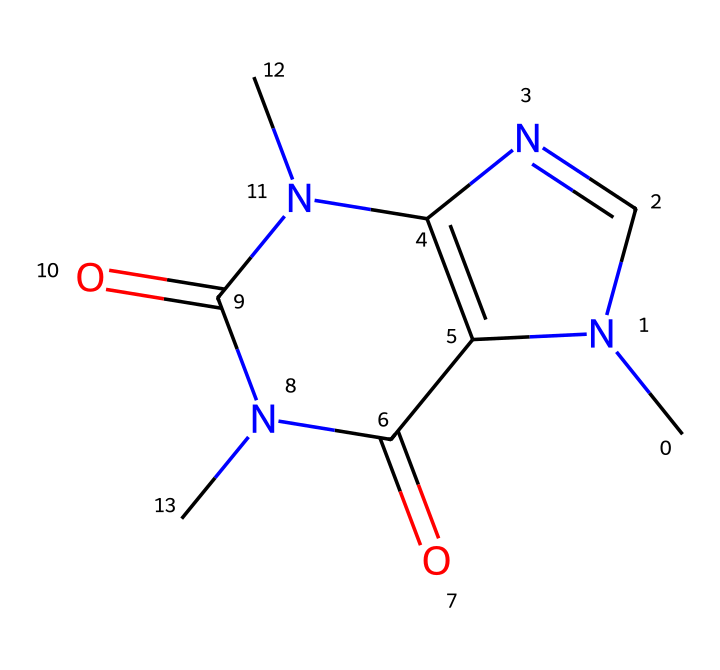What is the molecular formula of this caffeine compound? The molecular formula can be derived from the number of each type of atom present in the structure. By analyzing the SMILES representation, we can count the carbon (C), hydrogen (H), nitrogen (N), and oxygen (O) atoms. In this case, there are 8 carbon atoms, 10 hydrogen atoms, 4 nitrogen atoms, and 2 oxygen atoms. Therefore, the molecular formula is C8H10N4O2.
Answer: C8H10N4O2 How many nitrogen atoms are present in this chemical? Looking at the SMILES representation, we see multiple instances of 'N', which corresponds to nitrogen atoms. Counting these, we find there are 4 nitrogen atoms present in total.
Answer: 4 Is this compound classified as a stimulant? Caffeine is well-known for its stimulant properties, which increase alertness and decrease fatigue. This classification is based on its pharmacological effects rather than its chemical structure alone, but since this compound is caffeine, it falls under the stimulant category.
Answer: Yes What is the most likely effect of this drug on the human body? Caffeine typically acts as a central nervous system stimulant, leading to increased alertness and reduced fatigue. Its commonly known effect is to temporarily boost energy levels.
Answer: Increased alertness How many rings are present in the structure of this compound? By analyzing the structure from the SMILES representation, we can identify two interconnected ring systems. The numbers '1' and '2' in the SMILES indicate the start and end of the ring closures. Thus, we can conclude that there are two rings present.
Answer: 2 What is the type of this compound, specifically in terms of its drug class? This compound can be recognized as a methylxanthine class of drugs, characterized by its structure containing multiple nitrogen atoms and methyl groups. Methylxanthines include caffeine and others with similar structures.
Answer: Methylxanthine 